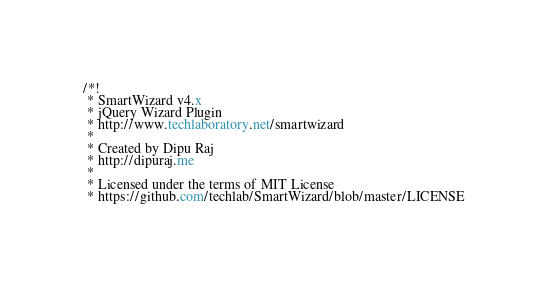<code> <loc_0><loc_0><loc_500><loc_500><_CSS_>/*!
 * SmartWizard v4.x
 * jQuery Wizard Plugin
 * http://www.techlaboratory.net/smartwizard
 *
 * Created by Dipu Raj
 * http://dipuraj.me
 *
 * Licensed under the terms of MIT License
 * https://github.com/techlab/SmartWizard/blob/master/LICENSE</code> 